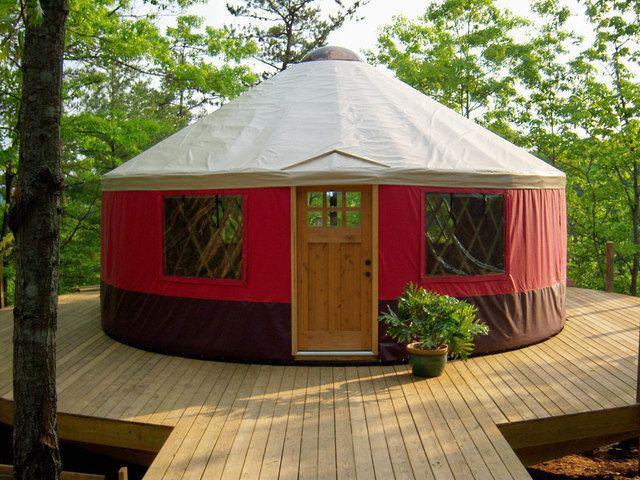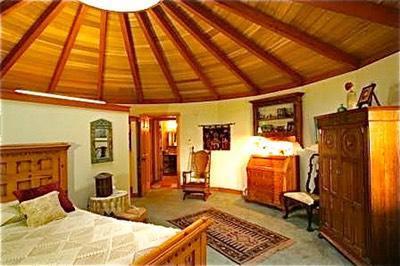The first image is the image on the left, the second image is the image on the right. Assess this claim about the two images: "At least one house has no visible windows.". Correct or not? Answer yes or no. Yes. 